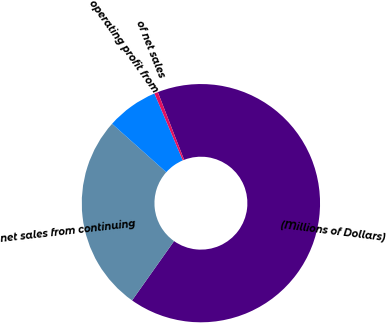Convert chart to OTSL. <chart><loc_0><loc_0><loc_500><loc_500><pie_chart><fcel>(Millions of Dollars)<fcel>net sales from continuing<fcel>operating profit from<fcel>of net sales<nl><fcel>65.69%<fcel>26.8%<fcel>7.01%<fcel>0.49%<nl></chart> 